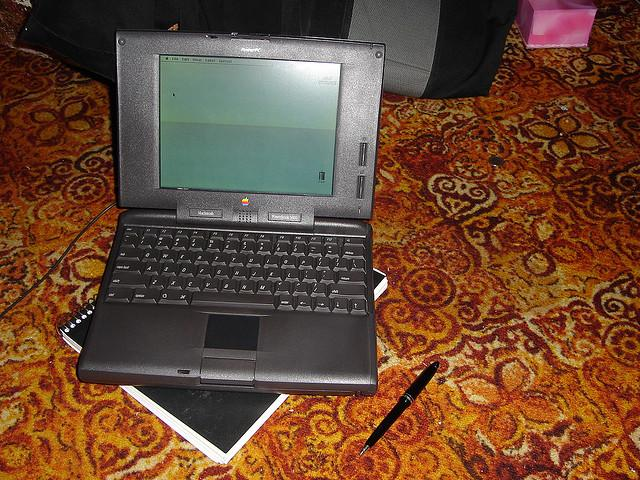What company made the black laptop on the black notebook? Please explain your reasoning. apple. There is a picture of a fruit on it 